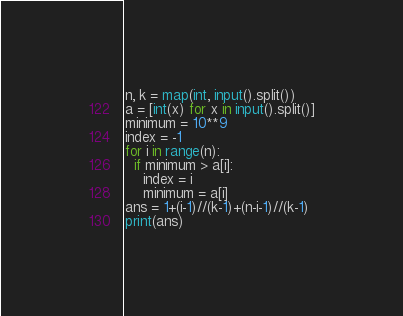<code> <loc_0><loc_0><loc_500><loc_500><_Python_>n, k = map(int, input().split())
a = [int(x) for x in input().split()]
minimum = 10**9
index = -1
for i in range(n):
  if minimum > a[i]:
    index = i
    minimum = a[i]
ans = 1+(i-1)//(k-1)+(n-i-1)//(k-1)
print(ans)</code> 